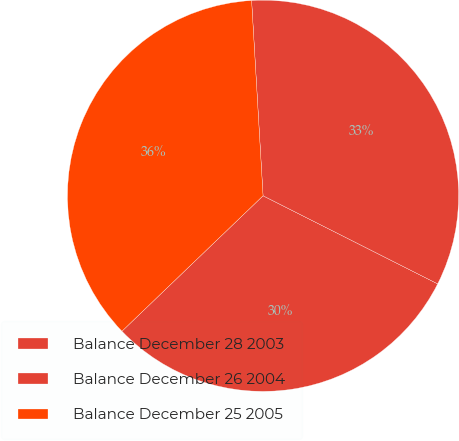Convert chart to OTSL. <chart><loc_0><loc_0><loc_500><loc_500><pie_chart><fcel>Balance December 28 2003<fcel>Balance December 26 2004<fcel>Balance December 25 2005<nl><fcel>30.39%<fcel>33.37%<fcel>36.24%<nl></chart> 